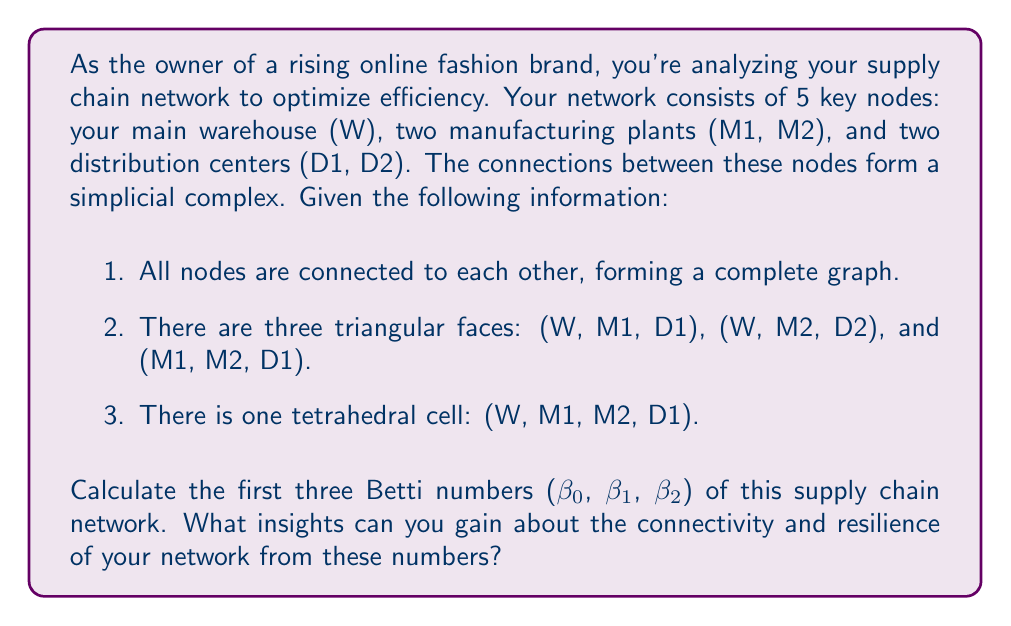Solve this math problem. To solve this problem, we need to use concepts from algebraic topology, specifically the calculation of Betti numbers. Let's approach this step-by-step:

1. First, let's count the simplices in each dimension:
   - 0-simplices (vertices): 5 (W, M1, M2, D1, D2)
   - 1-simplices (edges): $\binom{5}{2} = 10$ (complete graph)
   - 2-simplices (triangles): 3 (given in the problem)
   - 3-simplices (tetrahedra): 1 (given in the problem)

2. Now, let's calculate the ranks of the boundary maps:
   - rank($\partial_1$) = 4 (number of vertices minus 1)
   - rank($\partial_2$) = 7 (number of independent cycles in the graph)
   - rank($\partial_3$) = 3 (number of independent surfaces)

3. We can now calculate the Betti numbers using the formula:
   $\beta_k = \text{nullity}(\partial_k) - \text{rank}(\partial_{k+1})$

   Where nullity($\partial_k$) = number of k-simplices - rank($\partial_k$)

4. Calculating $\beta_0$:
   $\beta_0 = \text{nullity}(\partial_0) - \text{rank}(\partial_1) = 5 - 4 = 1$

5. Calculating $\beta_1$:
   $\beta_1 = \text{nullity}(\partial_1) - \text{rank}(\partial_2) = (10 - 4) - 3 = 3$

6. Calculating $\beta_2$:
   $\beta_2 = \text{nullity}(\partial_2) - \text{rank}(\partial_3) = (3 - 3) - 1 = -1$

   Since Betti numbers are non-negative, $\beta_2 = 0$

Insights from these Betti numbers:

1. $\beta_0 = 1$ indicates that the network is connected, with no isolated components.
2. $\beta_1 = 3$ represents the number of independent loops or alternative paths in the network, suggesting some redundancy and flexibility in the supply chain.
3. $\beta_2 = 0$ implies that there are no enclosed voids or cavities in the network structure.

These numbers suggest that your supply chain network has good connectivity and some built-in redundancy, which can be beneficial for resilience against disruptions. However, the lack of higher-dimensional structures (β₂ = 0) might indicate opportunities for creating more complex, interconnected subgroups within your supply chain for even greater robustness.
Answer: The Betti numbers of the supply chain network are:
$\beta_0 = 1$, $\beta_1 = 3$, $\beta_2 = 0$ 